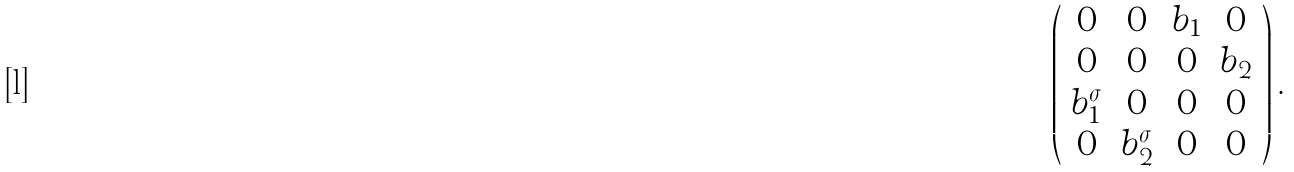Convert formula to latex. <formula><loc_0><loc_0><loc_500><loc_500>\left ( \begin{array} { c c c c } 0 & 0 & b _ { 1 } & 0 \\ 0 & 0 & 0 & b _ { 2 } \\ b _ { 1 } ^ { \sigma } & 0 & 0 & 0 \\ 0 & b _ { 2 } ^ { \sigma } & 0 & 0 \end{array} \right ) .</formula> 